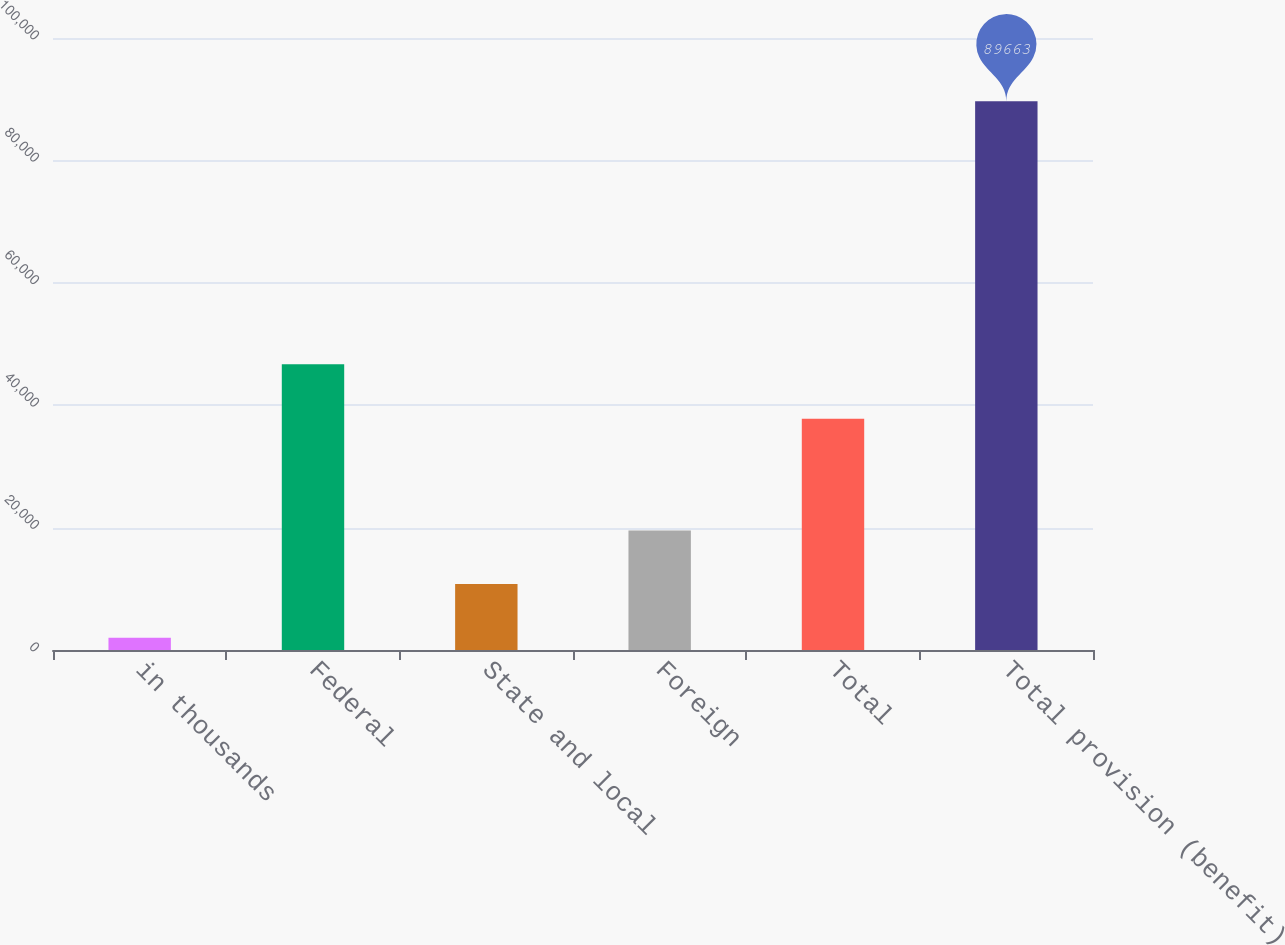Convert chart. <chart><loc_0><loc_0><loc_500><loc_500><bar_chart><fcel>in thousands<fcel>Federal<fcel>State and local<fcel>Foreign<fcel>Total<fcel>Total provision (benefit)<nl><fcel>2010<fcel>46671<fcel>10775.3<fcel>19540.6<fcel>37805<fcel>89663<nl></chart> 